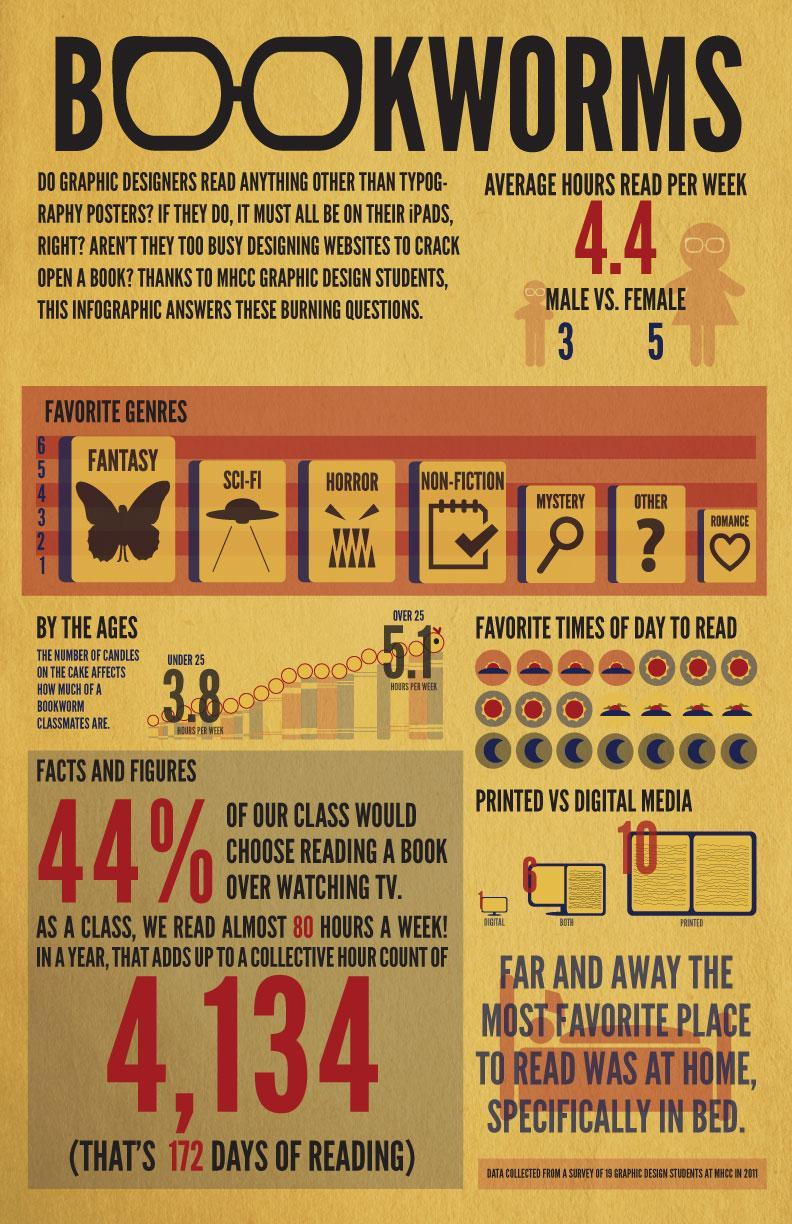How many students prefer printed book reading according to the survey of graphic designer students at MHCC in 2011?
Answer the question with a short phrase. 10 How many female students in MHCC spend an average of 4.4 hours per week on reading as per the survey in 2011? 5 How many male students in MHCC spend an average of 4.4 hours per week on reading as per the survey in 2011? 3 Which is the most favorite genre of books of graphic designer students in MHCC as per the survey in 2011? FANTASY Which is the least favorite genre of books of graphic designer students in MHCC as per the survey in 2011? ROMANCE How many students prefer e-reading according to the survey of graphic designer students at MHCC in 2011? 1 How many students like both digital & printed book reading according to the survey of graphic designer students at MHCC in 2011? 6 